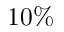<formula> <loc_0><loc_0><loc_500><loc_500>1 0 \%</formula> 